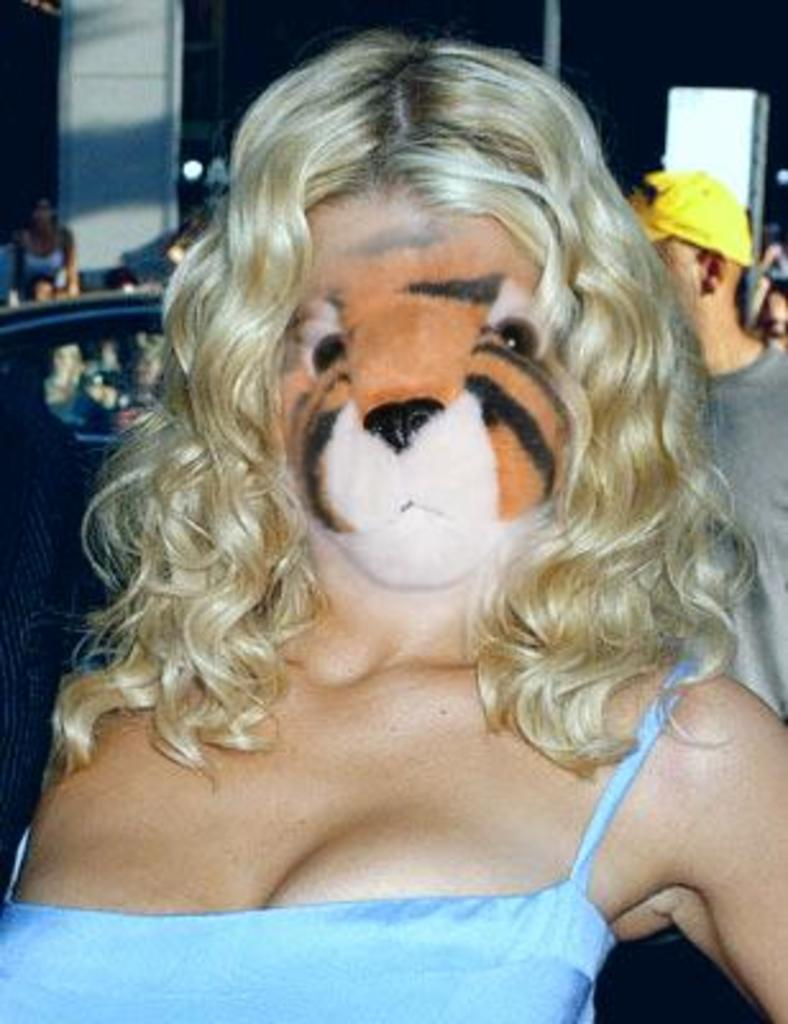What is the main subject of the image? There is a woman standing in the image. Can you describe the surroundings of the woman? There are people and a vehicle in the background of the image. How would you describe the lighting in the image? The background of the image appears to be dark. What type of oil is being used to turn the woman in the image? There is no oil or turning motion present in the image; the woman is standing still. 